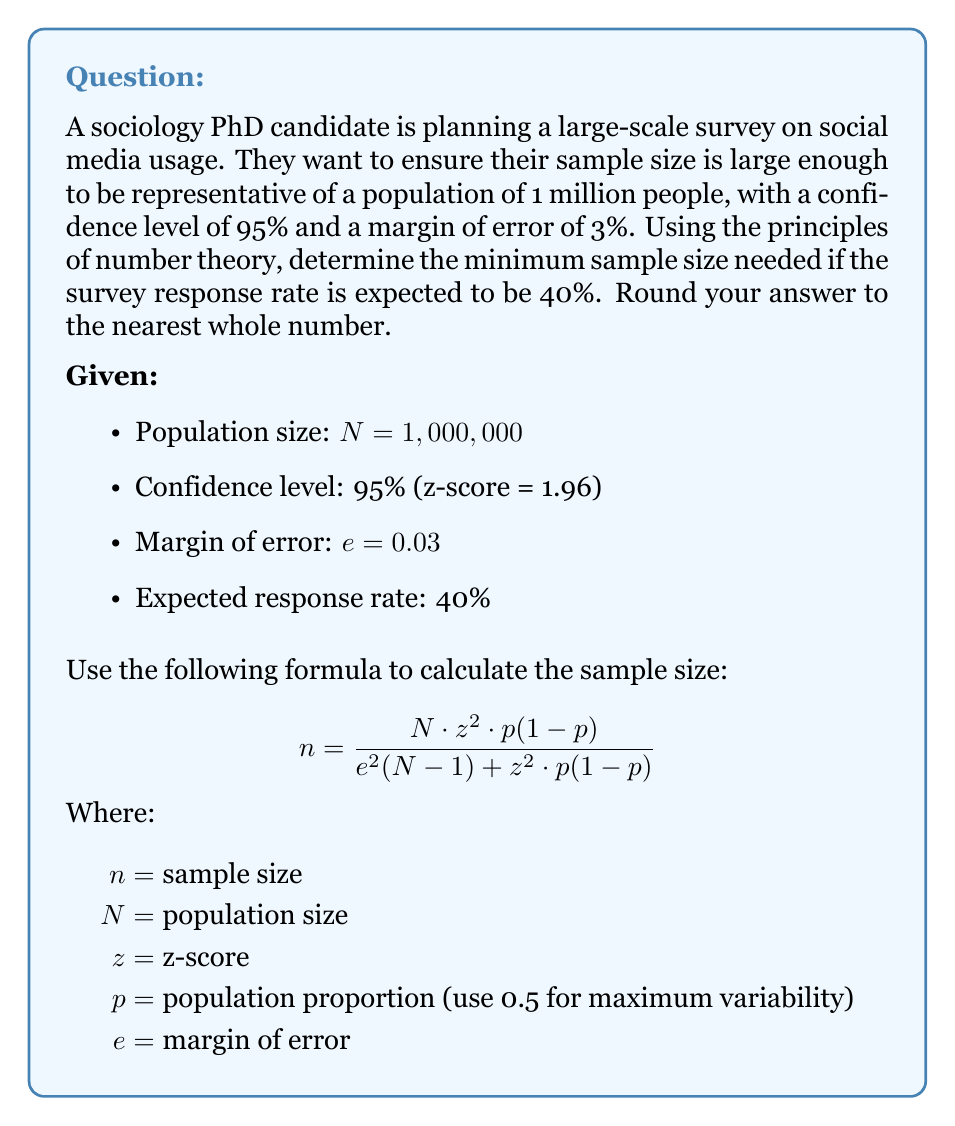Teach me how to tackle this problem. To solve this problem, we'll follow these steps:

1) First, let's plug in the known values into the sample size formula:

   $$ n = \frac{1,000,000 \cdot 1.96^2 \cdot 0.5(1-0.5)}{0.03^2(1,000,000-1) + 1.96^2 \cdot 0.5(1-0.5)} $$

2) Simplify the numerator:
   $1,000,000 \cdot 1.96^2 \cdot 0.5 \cdot 0.5 = 960,400$

3) Simplify the denominator:
   $0.03^2 \cdot 999,999 + 1.96^2 \cdot 0.5 \cdot 0.5 = 899.99 + 0.9604 = 900.9504$

4) Divide:
   $$ n = \frac{960,400}{900.9504} = 1,065.99 $$

5) Round to the nearest whole number:
   $n = 1,066$

6) However, this is the number of completed surveys needed. Since the expected response rate is 40%, we need to adjust our sample size:

   $$ \text{Adjusted sample size} = \frac{1,066}{0.40} = 2,665 $$

7) Round to the nearest whole number:
   Adjusted sample size = 2,665

Therefore, to achieve the desired confidence level and margin of error with an expected 40% response rate, the sociology PhD candidate needs to send out surveys to at least 2,665 people.
Answer: 2,665 people 